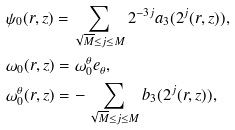Convert formula to latex. <formula><loc_0><loc_0><loc_500><loc_500>& \psi _ { 0 } ( r , z ) = \sum _ { \sqrt { M } \leq j \leq M } 2 ^ { - 3 j } a _ { 3 } ( 2 ^ { j } ( r , z ) ) , \\ & \omega _ { 0 } ( r , z ) = \omega _ { 0 } ^ { \theta } e _ { \theta } , \\ & \omega _ { 0 } ^ { \theta } ( r , z ) = - \sum _ { \sqrt { M } \leq j \leq M } b _ { 3 } ( 2 ^ { j } ( r , z ) ) ,</formula> 